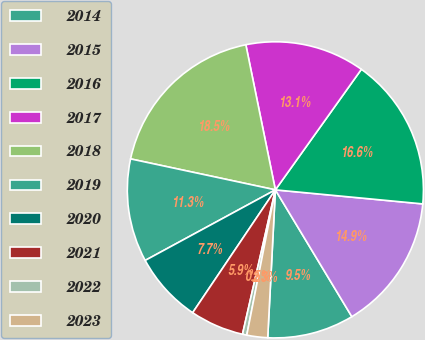<chart> <loc_0><loc_0><loc_500><loc_500><pie_chart><fcel>2014<fcel>2015<fcel>2016<fcel>2017<fcel>2018<fcel>2019<fcel>2020<fcel>2021<fcel>2022<fcel>2023<nl><fcel>9.46%<fcel>14.85%<fcel>16.65%<fcel>13.06%<fcel>18.45%<fcel>11.26%<fcel>7.66%<fcel>5.87%<fcel>0.47%<fcel>2.27%<nl></chart> 